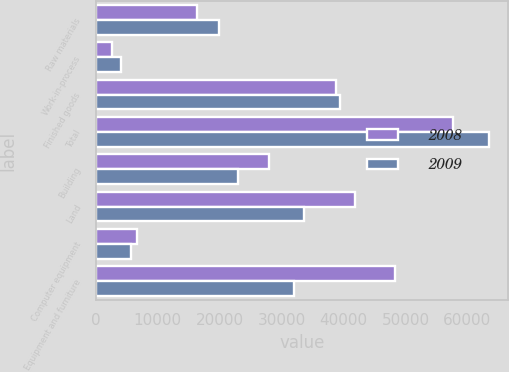Convert chart. <chart><loc_0><loc_0><loc_500><loc_500><stacked_bar_chart><ecel><fcel>Raw materials<fcel>Work-in-process<fcel>Finished goods<fcel>Total<fcel>Building<fcel>Land<fcel>Computer equipment<fcel>Equipment and furniture<nl><fcel>2008<fcel>16250<fcel>2537<fcel>38813<fcel>57600<fcel>28000<fcel>41771<fcel>6555<fcel>48236<nl><fcel>2009<fcel>19901<fcel>4097<fcel>39462<fcel>63460<fcel>22944<fcel>33571<fcel>5598<fcel>32020<nl></chart> 